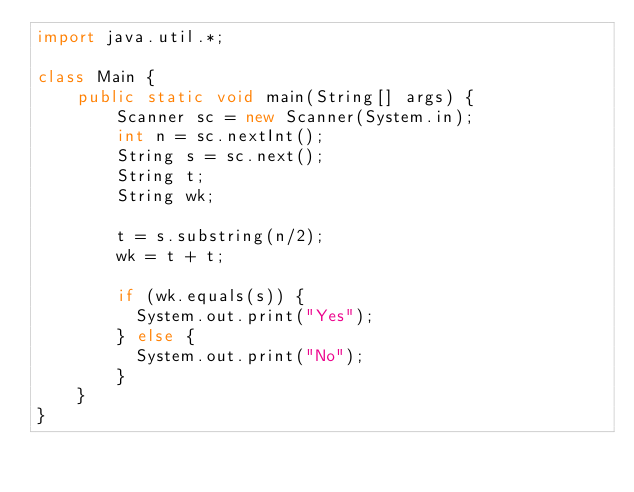Convert code to text. <code><loc_0><loc_0><loc_500><loc_500><_Java_>import java.util.*;
 
class Main {
    public static void main(String[] args) {
        Scanner sc = new Scanner(System.in);
        int n = sc.nextInt();
        String s = sc.next();
        String t;
        String wk;
      
        t = s.substring(n/2);
        wk = t + t;
      	
      	if (wk.equals(s)) {
          System.out.print("Yes");
        } else {
          System.out.print("No");
        }
    }
}</code> 